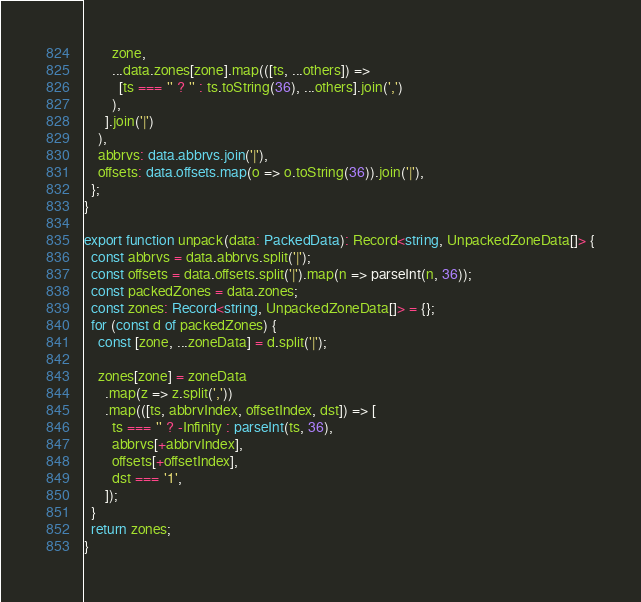Convert code to text. <code><loc_0><loc_0><loc_500><loc_500><_TypeScript_>        zone,
        ...data.zones[zone].map(([ts, ...others]) =>
          [ts === '' ? '' : ts.toString(36), ...others].join(',')
        ),
      ].join('|')
    ),
    abbrvs: data.abbrvs.join('|'),
    offsets: data.offsets.map(o => o.toString(36)).join('|'),
  };
}

export function unpack(data: PackedData): Record<string, UnpackedZoneData[]> {
  const abbrvs = data.abbrvs.split('|');
  const offsets = data.offsets.split('|').map(n => parseInt(n, 36));
  const packedZones = data.zones;
  const zones: Record<string, UnpackedZoneData[]> = {};
  for (const d of packedZones) {
    const [zone, ...zoneData] = d.split('|');

    zones[zone] = zoneData
      .map(z => z.split(','))
      .map(([ts, abbrvIndex, offsetIndex, dst]) => [
        ts === '' ? -Infinity : parseInt(ts, 36),
        abbrvs[+abbrvIndex],
        offsets[+offsetIndex],
        dst === '1',
      ]);
  }
  return zones;
}
</code> 